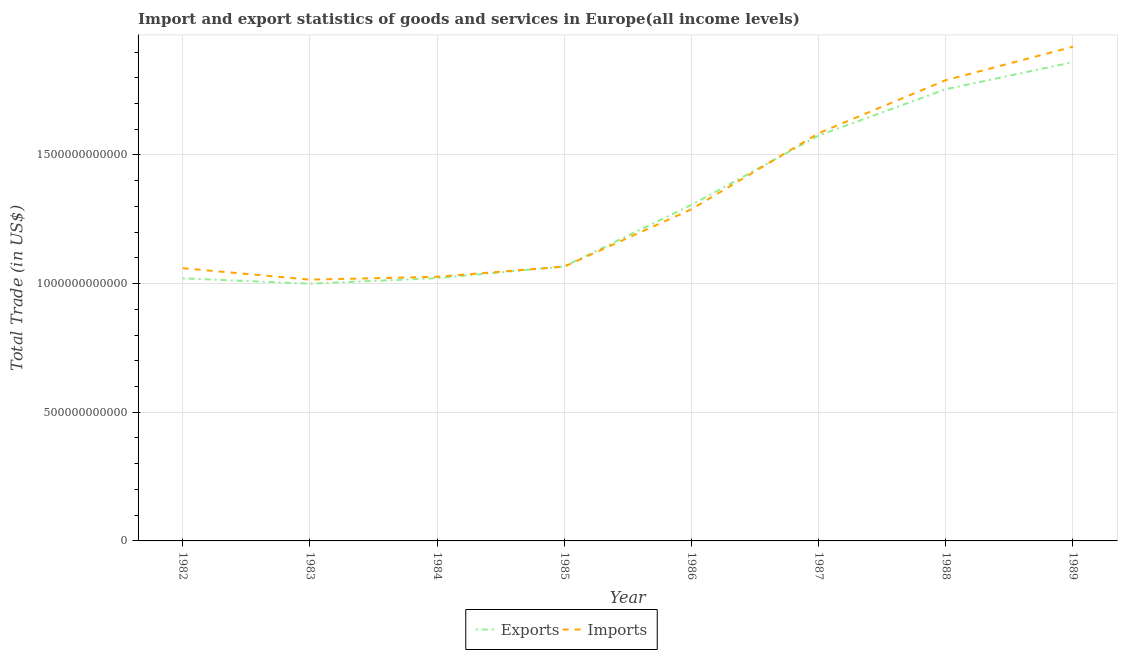Does the line corresponding to export of goods and services intersect with the line corresponding to imports of goods and services?
Your answer should be very brief. Yes. What is the export of goods and services in 1988?
Your answer should be very brief. 1.76e+12. Across all years, what is the maximum imports of goods and services?
Your answer should be compact. 1.92e+12. Across all years, what is the minimum export of goods and services?
Provide a succinct answer. 1.00e+12. What is the total imports of goods and services in the graph?
Offer a very short reply. 1.08e+13. What is the difference between the imports of goods and services in 1983 and that in 1989?
Offer a terse response. -9.05e+11. What is the difference between the imports of goods and services in 1989 and the export of goods and services in 1985?
Provide a short and direct response. 8.54e+11. What is the average imports of goods and services per year?
Keep it short and to the point. 1.34e+12. In the year 1982, what is the difference between the imports of goods and services and export of goods and services?
Ensure brevity in your answer.  3.95e+1. In how many years, is the export of goods and services greater than 500000000000 US$?
Keep it short and to the point. 8. What is the ratio of the export of goods and services in 1988 to that in 1989?
Offer a very short reply. 0.94. Is the export of goods and services in 1987 less than that in 1988?
Give a very brief answer. Yes. Is the difference between the imports of goods and services in 1984 and 1985 greater than the difference between the export of goods and services in 1984 and 1985?
Offer a very short reply. Yes. What is the difference between the highest and the second highest imports of goods and services?
Provide a short and direct response. 1.30e+11. What is the difference between the highest and the lowest export of goods and services?
Provide a succinct answer. 8.61e+11. In how many years, is the imports of goods and services greater than the average imports of goods and services taken over all years?
Offer a very short reply. 3. Is the sum of the imports of goods and services in 1983 and 1989 greater than the maximum export of goods and services across all years?
Give a very brief answer. Yes. Does the export of goods and services monotonically increase over the years?
Your response must be concise. No. Is the imports of goods and services strictly greater than the export of goods and services over the years?
Offer a very short reply. No. How many lines are there?
Offer a terse response. 2. How many years are there in the graph?
Provide a short and direct response. 8. What is the difference between two consecutive major ticks on the Y-axis?
Make the answer very short. 5.00e+11. Does the graph contain grids?
Provide a short and direct response. Yes. Where does the legend appear in the graph?
Provide a succinct answer. Bottom center. How are the legend labels stacked?
Offer a very short reply. Horizontal. What is the title of the graph?
Ensure brevity in your answer.  Import and export statistics of goods and services in Europe(all income levels). What is the label or title of the Y-axis?
Provide a succinct answer. Total Trade (in US$). What is the Total Trade (in US$) of Exports in 1982?
Your response must be concise. 1.02e+12. What is the Total Trade (in US$) in Imports in 1982?
Provide a short and direct response. 1.06e+12. What is the Total Trade (in US$) in Exports in 1983?
Make the answer very short. 1.00e+12. What is the Total Trade (in US$) of Imports in 1983?
Offer a very short reply. 1.02e+12. What is the Total Trade (in US$) of Exports in 1984?
Give a very brief answer. 1.02e+12. What is the Total Trade (in US$) in Imports in 1984?
Keep it short and to the point. 1.03e+12. What is the Total Trade (in US$) of Exports in 1985?
Provide a succinct answer. 1.07e+12. What is the Total Trade (in US$) of Imports in 1985?
Your answer should be compact. 1.07e+12. What is the Total Trade (in US$) of Exports in 1986?
Ensure brevity in your answer.  1.31e+12. What is the Total Trade (in US$) in Imports in 1986?
Offer a very short reply. 1.29e+12. What is the Total Trade (in US$) in Exports in 1987?
Provide a succinct answer. 1.58e+12. What is the Total Trade (in US$) of Imports in 1987?
Your answer should be compact. 1.58e+12. What is the Total Trade (in US$) in Exports in 1988?
Your answer should be very brief. 1.76e+12. What is the Total Trade (in US$) of Imports in 1988?
Offer a terse response. 1.79e+12. What is the Total Trade (in US$) of Exports in 1989?
Your response must be concise. 1.86e+12. What is the Total Trade (in US$) in Imports in 1989?
Offer a very short reply. 1.92e+12. Across all years, what is the maximum Total Trade (in US$) in Exports?
Ensure brevity in your answer.  1.86e+12. Across all years, what is the maximum Total Trade (in US$) of Imports?
Make the answer very short. 1.92e+12. Across all years, what is the minimum Total Trade (in US$) of Exports?
Ensure brevity in your answer.  1.00e+12. Across all years, what is the minimum Total Trade (in US$) of Imports?
Provide a short and direct response. 1.02e+12. What is the total Total Trade (in US$) in Exports in the graph?
Your answer should be compact. 1.06e+13. What is the total Total Trade (in US$) in Imports in the graph?
Provide a short and direct response. 1.08e+13. What is the difference between the Total Trade (in US$) in Exports in 1982 and that in 1983?
Make the answer very short. 2.06e+1. What is the difference between the Total Trade (in US$) in Imports in 1982 and that in 1983?
Keep it short and to the point. 4.45e+1. What is the difference between the Total Trade (in US$) of Exports in 1982 and that in 1984?
Offer a very short reply. -6.94e+08. What is the difference between the Total Trade (in US$) of Imports in 1982 and that in 1984?
Offer a terse response. 3.35e+1. What is the difference between the Total Trade (in US$) in Exports in 1982 and that in 1985?
Your answer should be compact. -4.63e+1. What is the difference between the Total Trade (in US$) of Imports in 1982 and that in 1985?
Provide a short and direct response. -6.29e+09. What is the difference between the Total Trade (in US$) in Exports in 1982 and that in 1986?
Keep it short and to the point. -2.85e+11. What is the difference between the Total Trade (in US$) in Imports in 1982 and that in 1986?
Provide a short and direct response. -2.29e+11. What is the difference between the Total Trade (in US$) of Exports in 1982 and that in 1987?
Make the answer very short. -5.55e+11. What is the difference between the Total Trade (in US$) in Imports in 1982 and that in 1987?
Offer a very short reply. -5.25e+11. What is the difference between the Total Trade (in US$) of Exports in 1982 and that in 1988?
Provide a short and direct response. -7.35e+11. What is the difference between the Total Trade (in US$) in Imports in 1982 and that in 1988?
Offer a terse response. -7.31e+11. What is the difference between the Total Trade (in US$) of Exports in 1982 and that in 1989?
Provide a short and direct response. -8.40e+11. What is the difference between the Total Trade (in US$) of Imports in 1982 and that in 1989?
Offer a terse response. -8.61e+11. What is the difference between the Total Trade (in US$) in Exports in 1983 and that in 1984?
Provide a succinct answer. -2.13e+1. What is the difference between the Total Trade (in US$) in Imports in 1983 and that in 1984?
Keep it short and to the point. -1.10e+1. What is the difference between the Total Trade (in US$) in Exports in 1983 and that in 1985?
Offer a very short reply. -6.69e+1. What is the difference between the Total Trade (in US$) in Imports in 1983 and that in 1985?
Ensure brevity in your answer.  -5.08e+1. What is the difference between the Total Trade (in US$) of Exports in 1983 and that in 1986?
Your answer should be very brief. -3.06e+11. What is the difference between the Total Trade (in US$) of Imports in 1983 and that in 1986?
Provide a succinct answer. -2.73e+11. What is the difference between the Total Trade (in US$) of Exports in 1983 and that in 1987?
Make the answer very short. -5.76e+11. What is the difference between the Total Trade (in US$) in Imports in 1983 and that in 1987?
Your answer should be compact. -5.69e+11. What is the difference between the Total Trade (in US$) of Exports in 1983 and that in 1988?
Your answer should be compact. -7.56e+11. What is the difference between the Total Trade (in US$) of Imports in 1983 and that in 1988?
Ensure brevity in your answer.  -7.75e+11. What is the difference between the Total Trade (in US$) of Exports in 1983 and that in 1989?
Give a very brief answer. -8.61e+11. What is the difference between the Total Trade (in US$) in Imports in 1983 and that in 1989?
Your answer should be compact. -9.05e+11. What is the difference between the Total Trade (in US$) of Exports in 1984 and that in 1985?
Offer a terse response. -4.56e+1. What is the difference between the Total Trade (in US$) in Imports in 1984 and that in 1985?
Offer a very short reply. -3.98e+1. What is the difference between the Total Trade (in US$) of Exports in 1984 and that in 1986?
Provide a short and direct response. -2.85e+11. What is the difference between the Total Trade (in US$) in Imports in 1984 and that in 1986?
Your answer should be compact. -2.62e+11. What is the difference between the Total Trade (in US$) in Exports in 1984 and that in 1987?
Your answer should be very brief. -5.54e+11. What is the difference between the Total Trade (in US$) of Imports in 1984 and that in 1987?
Keep it short and to the point. -5.58e+11. What is the difference between the Total Trade (in US$) of Exports in 1984 and that in 1988?
Make the answer very short. -7.34e+11. What is the difference between the Total Trade (in US$) of Imports in 1984 and that in 1988?
Your answer should be very brief. -7.64e+11. What is the difference between the Total Trade (in US$) of Exports in 1984 and that in 1989?
Make the answer very short. -8.39e+11. What is the difference between the Total Trade (in US$) in Imports in 1984 and that in 1989?
Provide a short and direct response. -8.94e+11. What is the difference between the Total Trade (in US$) in Exports in 1985 and that in 1986?
Your answer should be compact. -2.39e+11. What is the difference between the Total Trade (in US$) in Imports in 1985 and that in 1986?
Offer a terse response. -2.23e+11. What is the difference between the Total Trade (in US$) of Exports in 1985 and that in 1987?
Provide a succinct answer. -5.09e+11. What is the difference between the Total Trade (in US$) in Imports in 1985 and that in 1987?
Your answer should be very brief. -5.18e+11. What is the difference between the Total Trade (in US$) in Exports in 1985 and that in 1988?
Provide a succinct answer. -6.89e+11. What is the difference between the Total Trade (in US$) in Imports in 1985 and that in 1988?
Keep it short and to the point. -7.24e+11. What is the difference between the Total Trade (in US$) in Exports in 1985 and that in 1989?
Offer a very short reply. -7.94e+11. What is the difference between the Total Trade (in US$) in Imports in 1985 and that in 1989?
Give a very brief answer. -8.54e+11. What is the difference between the Total Trade (in US$) of Exports in 1986 and that in 1987?
Your response must be concise. -2.70e+11. What is the difference between the Total Trade (in US$) of Imports in 1986 and that in 1987?
Offer a terse response. -2.96e+11. What is the difference between the Total Trade (in US$) of Exports in 1986 and that in 1988?
Give a very brief answer. -4.50e+11. What is the difference between the Total Trade (in US$) of Imports in 1986 and that in 1988?
Provide a succinct answer. -5.02e+11. What is the difference between the Total Trade (in US$) of Exports in 1986 and that in 1989?
Provide a succinct answer. -5.55e+11. What is the difference between the Total Trade (in US$) in Imports in 1986 and that in 1989?
Your answer should be compact. -6.32e+11. What is the difference between the Total Trade (in US$) of Exports in 1987 and that in 1988?
Offer a very short reply. -1.80e+11. What is the difference between the Total Trade (in US$) in Imports in 1987 and that in 1988?
Provide a succinct answer. -2.06e+11. What is the difference between the Total Trade (in US$) of Exports in 1987 and that in 1989?
Your answer should be very brief. -2.85e+11. What is the difference between the Total Trade (in US$) of Imports in 1987 and that in 1989?
Offer a terse response. -3.36e+11. What is the difference between the Total Trade (in US$) of Exports in 1988 and that in 1989?
Offer a terse response. -1.05e+11. What is the difference between the Total Trade (in US$) of Imports in 1988 and that in 1989?
Offer a terse response. -1.30e+11. What is the difference between the Total Trade (in US$) of Exports in 1982 and the Total Trade (in US$) of Imports in 1983?
Your answer should be very brief. 5.01e+09. What is the difference between the Total Trade (in US$) of Exports in 1982 and the Total Trade (in US$) of Imports in 1984?
Offer a very short reply. -6.03e+09. What is the difference between the Total Trade (in US$) of Exports in 1982 and the Total Trade (in US$) of Imports in 1985?
Your answer should be compact. -4.58e+1. What is the difference between the Total Trade (in US$) in Exports in 1982 and the Total Trade (in US$) in Imports in 1986?
Offer a very short reply. -2.68e+11. What is the difference between the Total Trade (in US$) of Exports in 1982 and the Total Trade (in US$) of Imports in 1987?
Offer a terse response. -5.64e+11. What is the difference between the Total Trade (in US$) of Exports in 1982 and the Total Trade (in US$) of Imports in 1988?
Your answer should be very brief. -7.70e+11. What is the difference between the Total Trade (in US$) in Exports in 1982 and the Total Trade (in US$) in Imports in 1989?
Keep it short and to the point. -9.00e+11. What is the difference between the Total Trade (in US$) of Exports in 1983 and the Total Trade (in US$) of Imports in 1984?
Offer a very short reply. -2.67e+1. What is the difference between the Total Trade (in US$) in Exports in 1983 and the Total Trade (in US$) in Imports in 1985?
Offer a very short reply. -6.64e+1. What is the difference between the Total Trade (in US$) of Exports in 1983 and the Total Trade (in US$) of Imports in 1986?
Provide a succinct answer. -2.89e+11. What is the difference between the Total Trade (in US$) of Exports in 1983 and the Total Trade (in US$) of Imports in 1987?
Ensure brevity in your answer.  -5.85e+11. What is the difference between the Total Trade (in US$) in Exports in 1983 and the Total Trade (in US$) in Imports in 1988?
Offer a terse response. -7.91e+11. What is the difference between the Total Trade (in US$) of Exports in 1983 and the Total Trade (in US$) of Imports in 1989?
Offer a terse response. -9.21e+11. What is the difference between the Total Trade (in US$) of Exports in 1984 and the Total Trade (in US$) of Imports in 1985?
Your answer should be compact. -4.51e+1. What is the difference between the Total Trade (in US$) of Exports in 1984 and the Total Trade (in US$) of Imports in 1986?
Provide a short and direct response. -2.68e+11. What is the difference between the Total Trade (in US$) in Exports in 1984 and the Total Trade (in US$) in Imports in 1987?
Your answer should be compact. -5.63e+11. What is the difference between the Total Trade (in US$) of Exports in 1984 and the Total Trade (in US$) of Imports in 1988?
Ensure brevity in your answer.  -7.69e+11. What is the difference between the Total Trade (in US$) of Exports in 1984 and the Total Trade (in US$) of Imports in 1989?
Your answer should be very brief. -8.99e+11. What is the difference between the Total Trade (in US$) in Exports in 1985 and the Total Trade (in US$) in Imports in 1986?
Keep it short and to the point. -2.22e+11. What is the difference between the Total Trade (in US$) in Exports in 1985 and the Total Trade (in US$) in Imports in 1987?
Provide a succinct answer. -5.18e+11. What is the difference between the Total Trade (in US$) of Exports in 1985 and the Total Trade (in US$) of Imports in 1988?
Provide a succinct answer. -7.24e+11. What is the difference between the Total Trade (in US$) of Exports in 1985 and the Total Trade (in US$) of Imports in 1989?
Your answer should be very brief. -8.54e+11. What is the difference between the Total Trade (in US$) in Exports in 1986 and the Total Trade (in US$) in Imports in 1987?
Offer a terse response. -2.79e+11. What is the difference between the Total Trade (in US$) of Exports in 1986 and the Total Trade (in US$) of Imports in 1988?
Provide a succinct answer. -4.85e+11. What is the difference between the Total Trade (in US$) of Exports in 1986 and the Total Trade (in US$) of Imports in 1989?
Your answer should be compact. -6.15e+11. What is the difference between the Total Trade (in US$) in Exports in 1987 and the Total Trade (in US$) in Imports in 1988?
Offer a terse response. -2.15e+11. What is the difference between the Total Trade (in US$) in Exports in 1987 and the Total Trade (in US$) in Imports in 1989?
Your response must be concise. -3.45e+11. What is the difference between the Total Trade (in US$) in Exports in 1988 and the Total Trade (in US$) in Imports in 1989?
Offer a very short reply. -1.65e+11. What is the average Total Trade (in US$) of Exports per year?
Your answer should be compact. 1.33e+12. What is the average Total Trade (in US$) in Imports per year?
Make the answer very short. 1.34e+12. In the year 1982, what is the difference between the Total Trade (in US$) of Exports and Total Trade (in US$) of Imports?
Your answer should be compact. -3.95e+1. In the year 1983, what is the difference between the Total Trade (in US$) in Exports and Total Trade (in US$) in Imports?
Give a very brief answer. -1.56e+1. In the year 1984, what is the difference between the Total Trade (in US$) in Exports and Total Trade (in US$) in Imports?
Provide a short and direct response. -5.33e+09. In the year 1985, what is the difference between the Total Trade (in US$) in Exports and Total Trade (in US$) in Imports?
Your answer should be very brief. 5.13e+08. In the year 1986, what is the difference between the Total Trade (in US$) of Exports and Total Trade (in US$) of Imports?
Give a very brief answer. 1.69e+1. In the year 1987, what is the difference between the Total Trade (in US$) of Exports and Total Trade (in US$) of Imports?
Provide a succinct answer. -9.00e+09. In the year 1988, what is the difference between the Total Trade (in US$) of Exports and Total Trade (in US$) of Imports?
Provide a succinct answer. -3.51e+1. In the year 1989, what is the difference between the Total Trade (in US$) of Exports and Total Trade (in US$) of Imports?
Make the answer very short. -6.01e+1. What is the ratio of the Total Trade (in US$) of Exports in 1982 to that in 1983?
Make the answer very short. 1.02. What is the ratio of the Total Trade (in US$) in Imports in 1982 to that in 1983?
Provide a short and direct response. 1.04. What is the ratio of the Total Trade (in US$) of Exports in 1982 to that in 1984?
Give a very brief answer. 1. What is the ratio of the Total Trade (in US$) of Imports in 1982 to that in 1984?
Ensure brevity in your answer.  1.03. What is the ratio of the Total Trade (in US$) in Exports in 1982 to that in 1985?
Make the answer very short. 0.96. What is the ratio of the Total Trade (in US$) in Imports in 1982 to that in 1985?
Ensure brevity in your answer.  0.99. What is the ratio of the Total Trade (in US$) of Exports in 1982 to that in 1986?
Your answer should be very brief. 0.78. What is the ratio of the Total Trade (in US$) of Imports in 1982 to that in 1986?
Give a very brief answer. 0.82. What is the ratio of the Total Trade (in US$) in Exports in 1982 to that in 1987?
Keep it short and to the point. 0.65. What is the ratio of the Total Trade (in US$) of Imports in 1982 to that in 1987?
Your answer should be compact. 0.67. What is the ratio of the Total Trade (in US$) of Exports in 1982 to that in 1988?
Your response must be concise. 0.58. What is the ratio of the Total Trade (in US$) in Imports in 1982 to that in 1988?
Provide a succinct answer. 0.59. What is the ratio of the Total Trade (in US$) of Exports in 1982 to that in 1989?
Your answer should be compact. 0.55. What is the ratio of the Total Trade (in US$) of Imports in 1982 to that in 1989?
Your response must be concise. 0.55. What is the ratio of the Total Trade (in US$) in Exports in 1983 to that in 1984?
Keep it short and to the point. 0.98. What is the ratio of the Total Trade (in US$) in Exports in 1983 to that in 1985?
Offer a terse response. 0.94. What is the ratio of the Total Trade (in US$) in Exports in 1983 to that in 1986?
Your answer should be compact. 0.77. What is the ratio of the Total Trade (in US$) of Imports in 1983 to that in 1986?
Your answer should be compact. 0.79. What is the ratio of the Total Trade (in US$) in Exports in 1983 to that in 1987?
Your answer should be very brief. 0.63. What is the ratio of the Total Trade (in US$) in Imports in 1983 to that in 1987?
Keep it short and to the point. 0.64. What is the ratio of the Total Trade (in US$) in Exports in 1983 to that in 1988?
Your answer should be compact. 0.57. What is the ratio of the Total Trade (in US$) in Imports in 1983 to that in 1988?
Your answer should be compact. 0.57. What is the ratio of the Total Trade (in US$) in Exports in 1983 to that in 1989?
Your answer should be very brief. 0.54. What is the ratio of the Total Trade (in US$) in Imports in 1983 to that in 1989?
Offer a terse response. 0.53. What is the ratio of the Total Trade (in US$) of Exports in 1984 to that in 1985?
Your answer should be compact. 0.96. What is the ratio of the Total Trade (in US$) in Imports in 1984 to that in 1985?
Your answer should be compact. 0.96. What is the ratio of the Total Trade (in US$) in Exports in 1984 to that in 1986?
Ensure brevity in your answer.  0.78. What is the ratio of the Total Trade (in US$) of Imports in 1984 to that in 1986?
Offer a terse response. 0.8. What is the ratio of the Total Trade (in US$) of Exports in 1984 to that in 1987?
Offer a very short reply. 0.65. What is the ratio of the Total Trade (in US$) in Imports in 1984 to that in 1987?
Ensure brevity in your answer.  0.65. What is the ratio of the Total Trade (in US$) in Exports in 1984 to that in 1988?
Offer a terse response. 0.58. What is the ratio of the Total Trade (in US$) of Imports in 1984 to that in 1988?
Keep it short and to the point. 0.57. What is the ratio of the Total Trade (in US$) in Exports in 1984 to that in 1989?
Provide a short and direct response. 0.55. What is the ratio of the Total Trade (in US$) in Imports in 1984 to that in 1989?
Provide a short and direct response. 0.53. What is the ratio of the Total Trade (in US$) in Exports in 1985 to that in 1986?
Provide a succinct answer. 0.82. What is the ratio of the Total Trade (in US$) in Imports in 1985 to that in 1986?
Offer a very short reply. 0.83. What is the ratio of the Total Trade (in US$) of Exports in 1985 to that in 1987?
Provide a short and direct response. 0.68. What is the ratio of the Total Trade (in US$) in Imports in 1985 to that in 1987?
Provide a succinct answer. 0.67. What is the ratio of the Total Trade (in US$) in Exports in 1985 to that in 1988?
Your response must be concise. 0.61. What is the ratio of the Total Trade (in US$) in Imports in 1985 to that in 1988?
Provide a short and direct response. 0.6. What is the ratio of the Total Trade (in US$) in Exports in 1985 to that in 1989?
Provide a succinct answer. 0.57. What is the ratio of the Total Trade (in US$) in Imports in 1985 to that in 1989?
Make the answer very short. 0.56. What is the ratio of the Total Trade (in US$) in Exports in 1986 to that in 1987?
Provide a short and direct response. 0.83. What is the ratio of the Total Trade (in US$) in Imports in 1986 to that in 1987?
Your response must be concise. 0.81. What is the ratio of the Total Trade (in US$) of Exports in 1986 to that in 1988?
Your answer should be compact. 0.74. What is the ratio of the Total Trade (in US$) of Imports in 1986 to that in 1988?
Your answer should be very brief. 0.72. What is the ratio of the Total Trade (in US$) in Exports in 1986 to that in 1989?
Ensure brevity in your answer.  0.7. What is the ratio of the Total Trade (in US$) of Imports in 1986 to that in 1989?
Give a very brief answer. 0.67. What is the ratio of the Total Trade (in US$) of Exports in 1987 to that in 1988?
Your response must be concise. 0.9. What is the ratio of the Total Trade (in US$) in Imports in 1987 to that in 1988?
Ensure brevity in your answer.  0.88. What is the ratio of the Total Trade (in US$) of Exports in 1987 to that in 1989?
Keep it short and to the point. 0.85. What is the ratio of the Total Trade (in US$) in Imports in 1987 to that in 1989?
Make the answer very short. 0.82. What is the ratio of the Total Trade (in US$) in Exports in 1988 to that in 1989?
Your response must be concise. 0.94. What is the ratio of the Total Trade (in US$) of Imports in 1988 to that in 1989?
Ensure brevity in your answer.  0.93. What is the difference between the highest and the second highest Total Trade (in US$) in Exports?
Offer a terse response. 1.05e+11. What is the difference between the highest and the second highest Total Trade (in US$) of Imports?
Ensure brevity in your answer.  1.30e+11. What is the difference between the highest and the lowest Total Trade (in US$) of Exports?
Keep it short and to the point. 8.61e+11. What is the difference between the highest and the lowest Total Trade (in US$) of Imports?
Offer a terse response. 9.05e+11. 